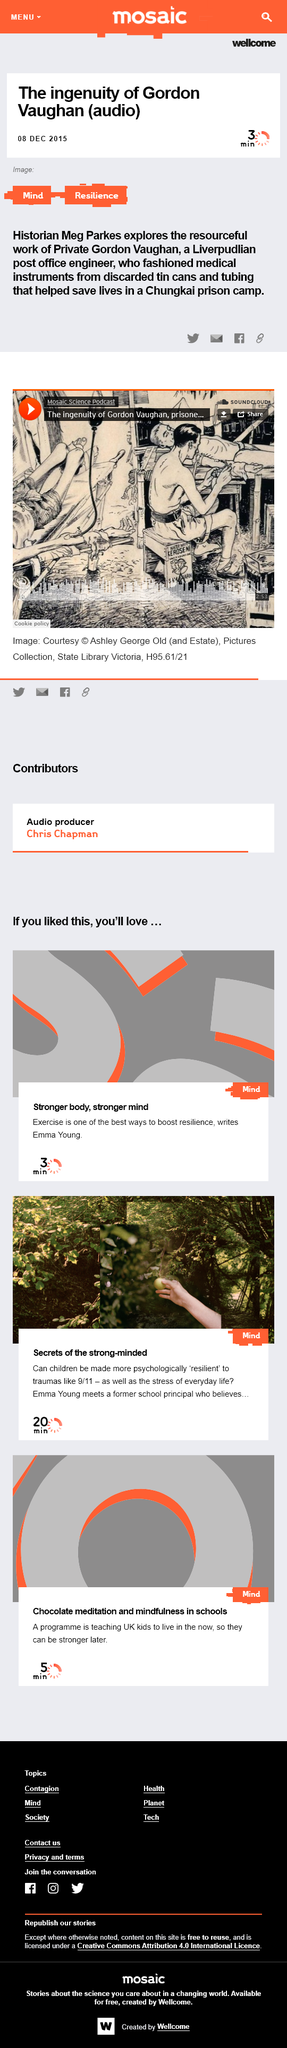Identify some key points in this picture. The person featured in the article is named Emma Young. Exercise is cited in the article as one of the best ways to boost resilience. Gordon Vaughan was from Liverpool. Gordon Vaughan, while imprisoned in a camp, fashioned medical instruments from discarded materials, thereby demonstrating his resourcefulness and ingenuity in the face of adversity. The United Kingdom is educating its children to adapt to the current lifestyle. 